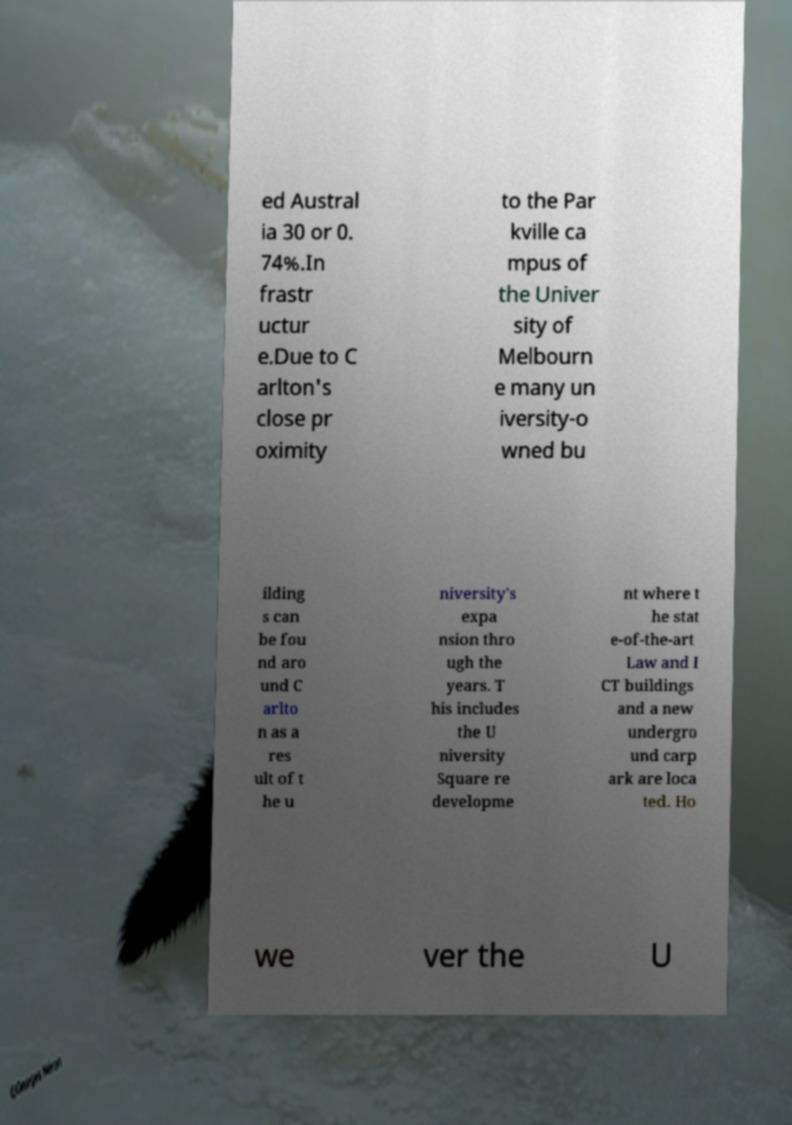Could you assist in decoding the text presented in this image and type it out clearly? ed Austral ia 30 or 0. 74%.In frastr uctur e.Due to C arlton's close pr oximity to the Par kville ca mpus of the Univer sity of Melbourn e many un iversity-o wned bu ilding s can be fou nd aro und C arlto n as a res ult of t he u niversity's expa nsion thro ugh the years. T his includes the U niversity Square re developme nt where t he stat e-of-the-art Law and I CT buildings and a new undergro und carp ark are loca ted. Ho we ver the U 